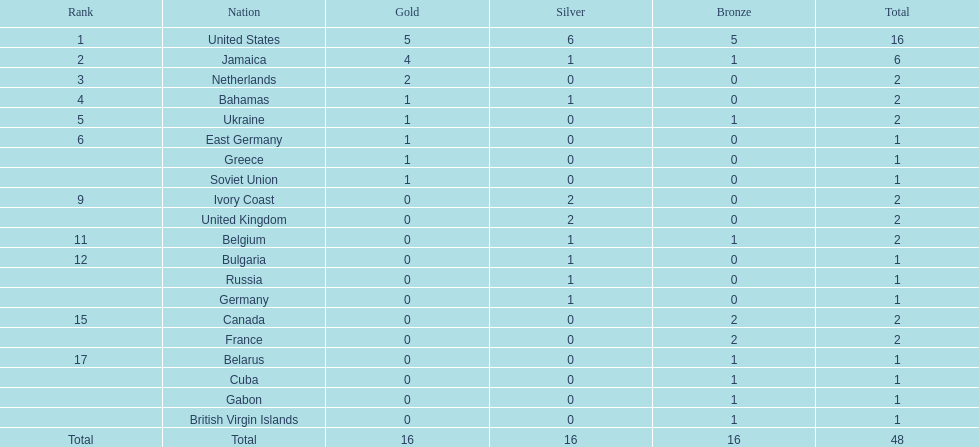What country won more gold medals than any other? United States. 